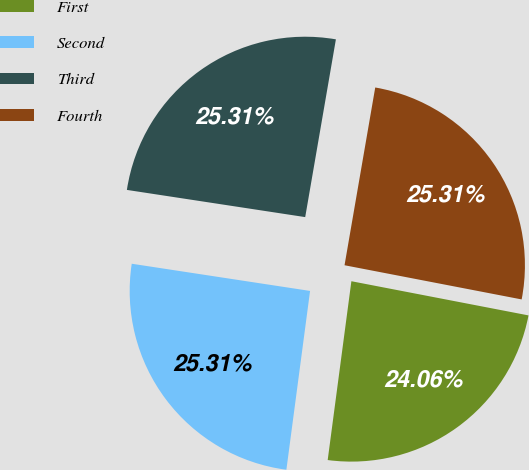Convert chart to OTSL. <chart><loc_0><loc_0><loc_500><loc_500><pie_chart><fcel>First<fcel>Second<fcel>Third<fcel>Fourth<nl><fcel>24.06%<fcel>25.31%<fcel>25.31%<fcel>25.31%<nl></chart> 